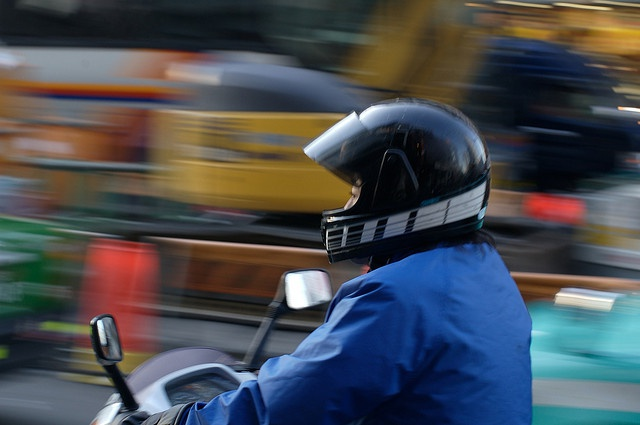Describe the objects in this image and their specific colors. I can see people in black, navy, blue, and gray tones, motorcycle in black, gray, and lightgray tones, and potted plant in black, gray, darkgreen, and teal tones in this image. 